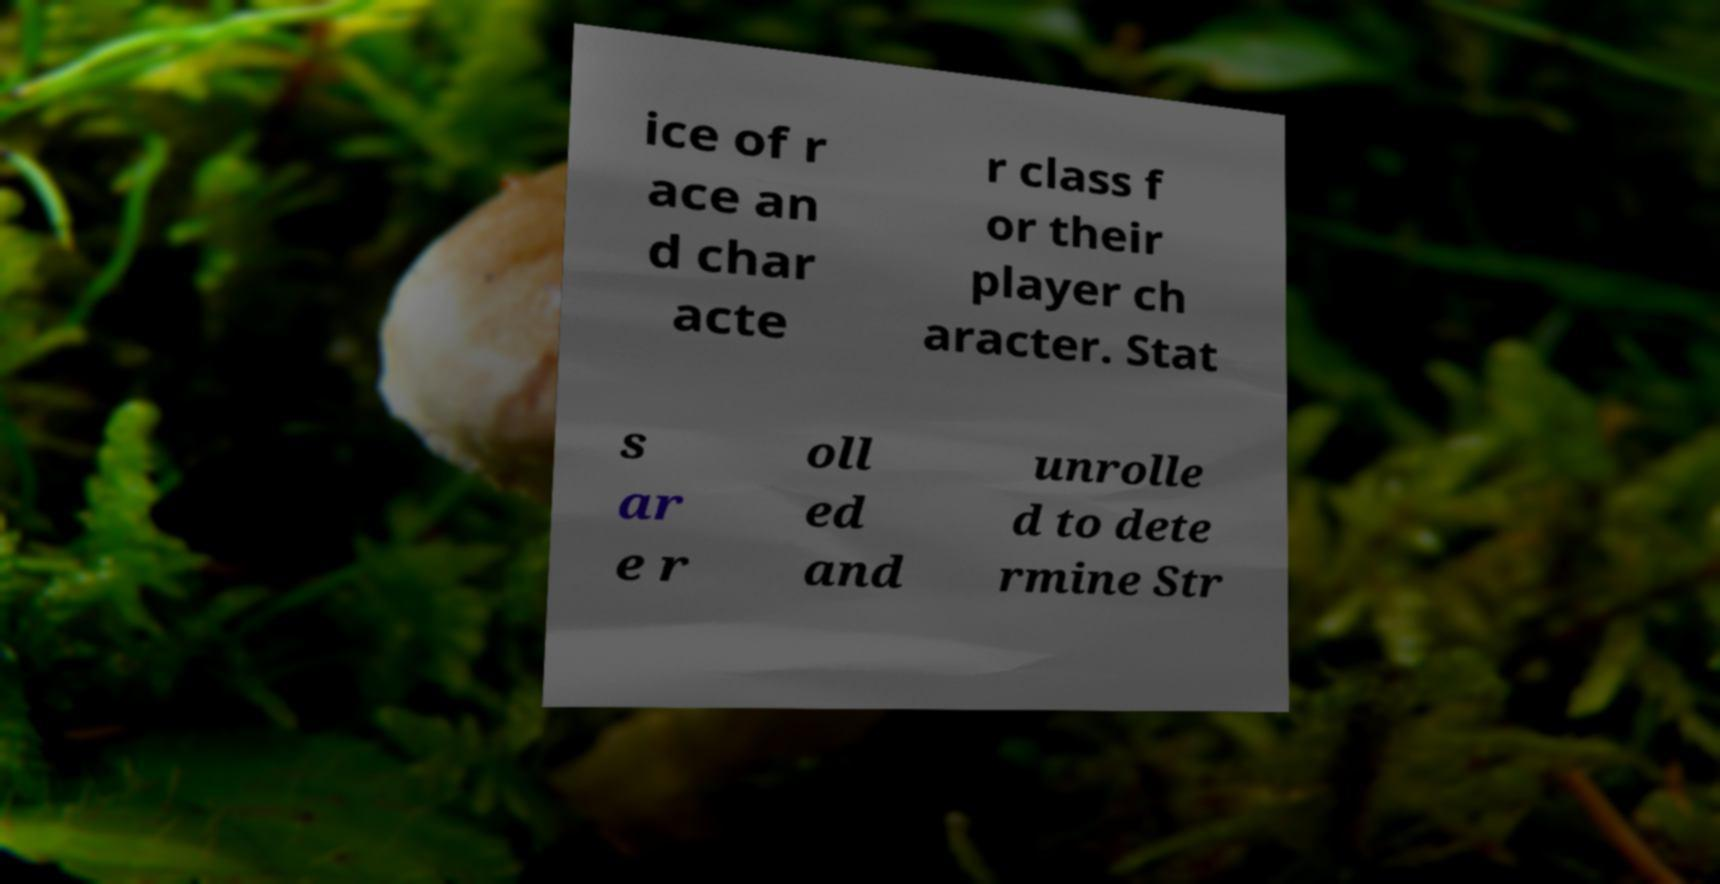Can you read and provide the text displayed in the image?This photo seems to have some interesting text. Can you extract and type it out for me? ice of r ace an d char acte r class f or their player ch aracter. Stat s ar e r oll ed and unrolle d to dete rmine Str 